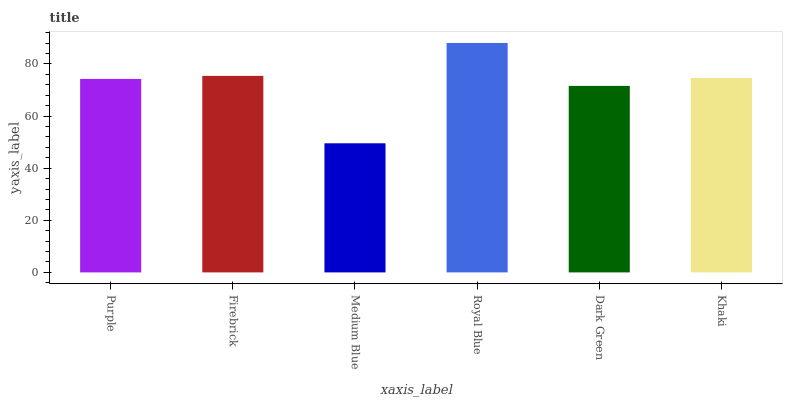Is Medium Blue the minimum?
Answer yes or no. Yes. Is Royal Blue the maximum?
Answer yes or no. Yes. Is Firebrick the minimum?
Answer yes or no. No. Is Firebrick the maximum?
Answer yes or no. No. Is Firebrick greater than Purple?
Answer yes or no. Yes. Is Purple less than Firebrick?
Answer yes or no. Yes. Is Purple greater than Firebrick?
Answer yes or no. No. Is Firebrick less than Purple?
Answer yes or no. No. Is Khaki the high median?
Answer yes or no. Yes. Is Purple the low median?
Answer yes or no. Yes. Is Dark Green the high median?
Answer yes or no. No. Is Dark Green the low median?
Answer yes or no. No. 